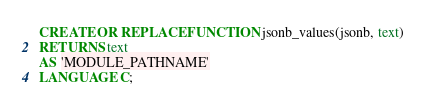<code> <loc_0><loc_0><loc_500><loc_500><_SQL_>CREATE OR REPLACE FUNCTION jsonb_values(jsonb, text)
RETURNS text
AS 'MODULE_PATHNAME'
LANGUAGE C;
</code> 